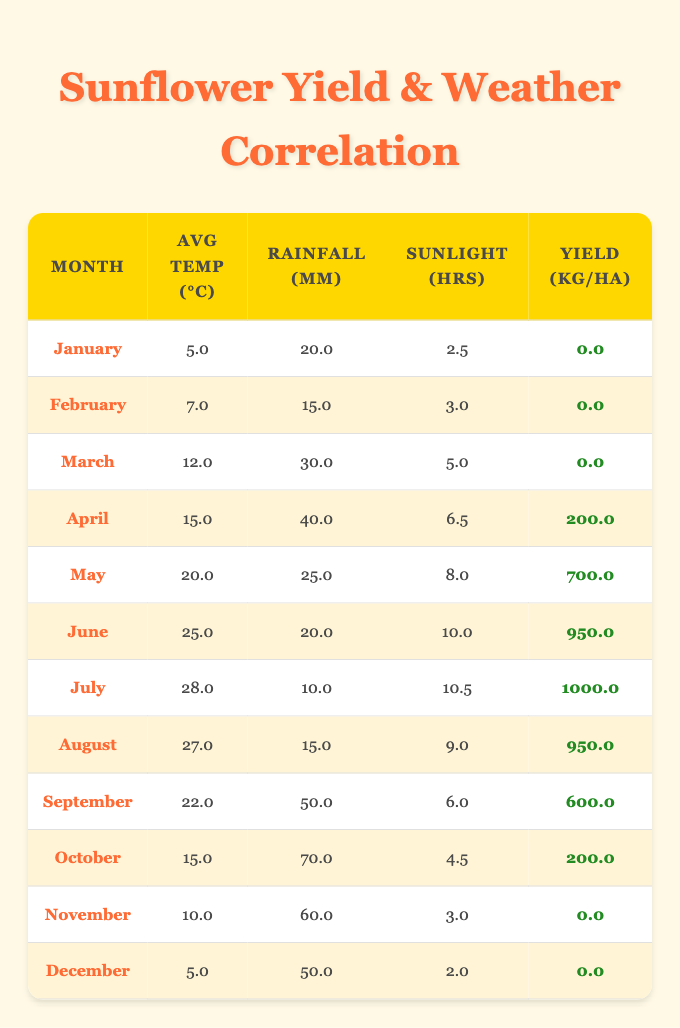What was the sunflower yield in July? In the table, July has a sunflower yield value of 1000.0 kg per hectare, indicated in the relevant row under the "Yield (kg/ha)" column.
Answer: 1000.0 kg/ha Which month had the highest average temperature? Looking through the table, July has the highest average temperature of 28.0 °C, which is the maximum value in the "Avg Temp (°C)" column for all the months listed.
Answer: July What is the total rainfall recorded in September? Referring to the table, the total rainfall for September is 50.0 mm, as shown in the corresponding row under the "Rainfall (mm)" column.
Answer: 50.0 mm Is it true that the sunflower yield was zero in the months of January, February, and March? Checking the "Yield (kg/ha)" column for these months, all three months (January, February, March) indeed have a yield of 0.0 kg per hectare, confirming that the statement is true.
Answer: True What month had the most sunlight hours and what was the yield in that month? In the table, July has the most sunlight hours recorded at 10.5 hours, and the corresponding "Yield (kg/ha)" value for July is 1000.0 kg per hectare. This indicates that July had both the most sunlight and a high sunflower yield.
Answer: July, 1000.0 kg/ha What is the average sunflower yield from April to August? The yields from April to August are: April (200.0), May (700.0), June (950.0), July (1000.0), and August (950.0). Summing these values gives 200.0 + 700.0 + 950.0 + 1000.0 + 950.0 = 3850.0 kg. Dividing by the 5 months provides the average yield, which is 3850.0/5 = 770.0 kg per hectare.
Answer: 770.0 kg/ha How does the average rainfall in March compare to that in November? The average rainfall in March is 30.0 mm, while in November it is 60.0 mm. Since 60.0 mm is greater than 30.0 mm, the November rainfall is higher. Therefore, it can be concluded that the average rainfall in November exceeds that of March.
Answer: November has higher rainfall What was the sunflower yield in the month with the least average sunlight hours? January has the least average sunlight hours at 2.5, and in the corresponding row, the yield is 0.0 kg per hectare. Thus, January had the least sunlight hours and also had zero yield.
Answer: 0.0 kg/ha 